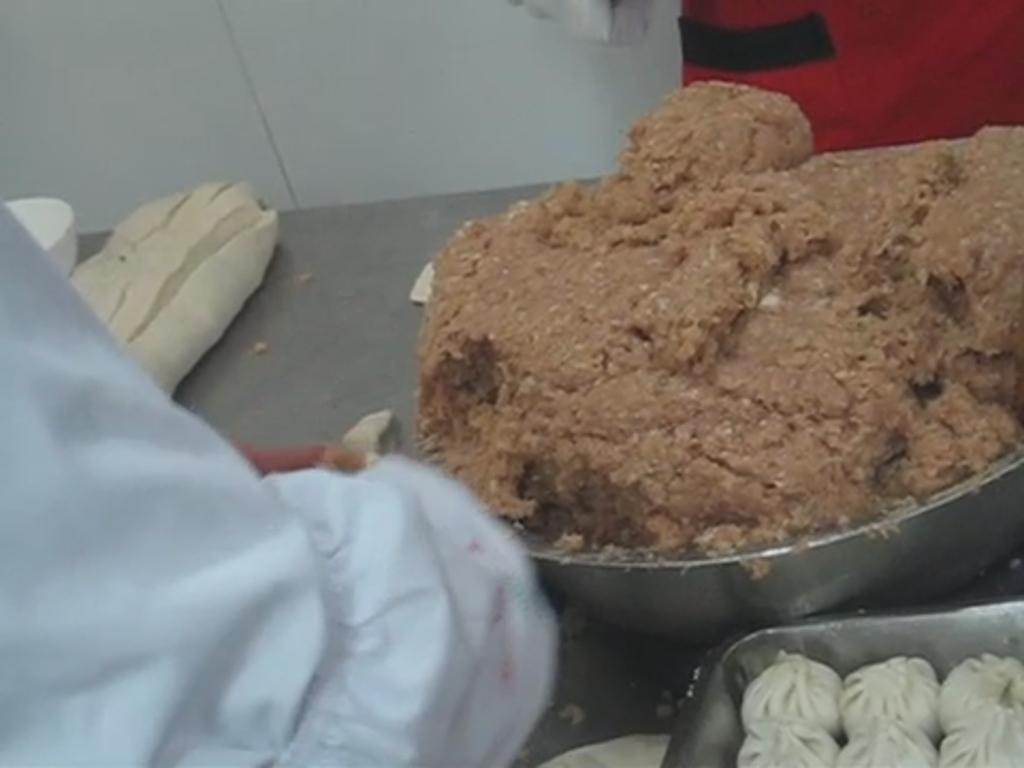What types of items can be seen in the image? There are food items in the image. What objects are present on the table? There are containers on the table. Can you describe the background of the image? There are people visible in the background, and there is a wall in the background. What is the desire of the spiders crawling on the chin of the person in the image? There are no spiders or chins present in the image, so it is not possible to answer that question. 